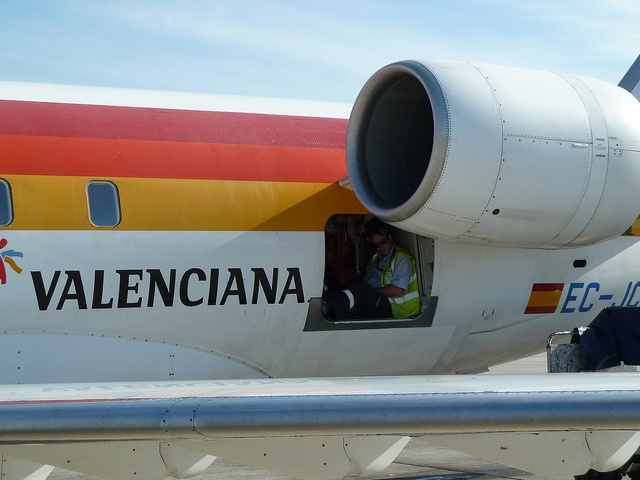Describe the objects in this image and their specific colors. I can see airplane in lightblue, darkgray, gray, black, and lightgray tones and people in lightblue, black, darkgreen, blue, and gray tones in this image. 